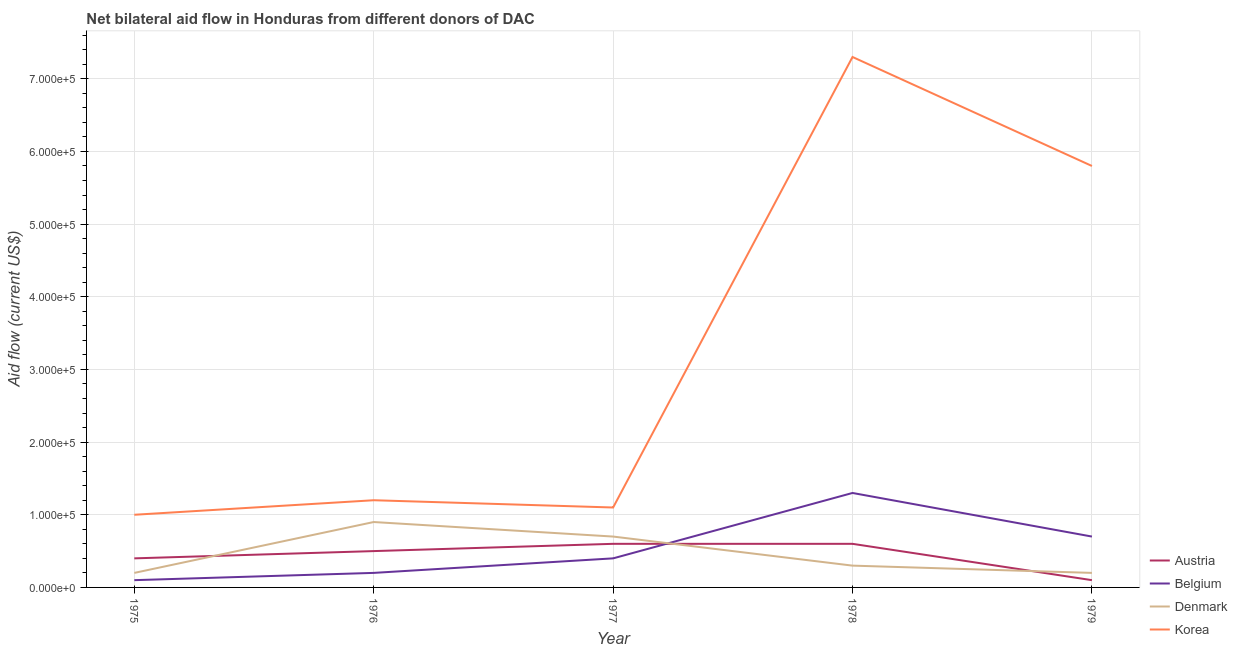Is the number of lines equal to the number of legend labels?
Provide a short and direct response. Yes. What is the amount of aid given by austria in 1978?
Your answer should be very brief. 6.00e+04. Across all years, what is the maximum amount of aid given by austria?
Your response must be concise. 6.00e+04. Across all years, what is the minimum amount of aid given by denmark?
Provide a short and direct response. 2.00e+04. In which year was the amount of aid given by austria minimum?
Offer a very short reply. 1979. What is the total amount of aid given by belgium in the graph?
Ensure brevity in your answer.  2.70e+05. What is the difference between the amount of aid given by austria in 1976 and that in 1977?
Provide a succinct answer. -10000. What is the difference between the amount of aid given by austria in 1975 and the amount of aid given by korea in 1977?
Offer a terse response. -7.00e+04. What is the average amount of aid given by denmark per year?
Make the answer very short. 4.60e+04. In the year 1979, what is the difference between the amount of aid given by belgium and amount of aid given by austria?
Ensure brevity in your answer.  6.00e+04. What is the ratio of the amount of aid given by denmark in 1977 to that in 1978?
Your response must be concise. 2.33. Is the amount of aid given by belgium in 1977 less than that in 1978?
Give a very brief answer. Yes. Is the difference between the amount of aid given by belgium in 1976 and 1978 greater than the difference between the amount of aid given by korea in 1976 and 1978?
Make the answer very short. Yes. What is the difference between the highest and the lowest amount of aid given by korea?
Ensure brevity in your answer.  6.30e+05. In how many years, is the amount of aid given by belgium greater than the average amount of aid given by belgium taken over all years?
Your answer should be compact. 2. Is the sum of the amount of aid given by korea in 1975 and 1976 greater than the maximum amount of aid given by belgium across all years?
Your answer should be very brief. Yes. Is it the case that in every year, the sum of the amount of aid given by denmark and amount of aid given by korea is greater than the sum of amount of aid given by austria and amount of aid given by belgium?
Keep it short and to the point. No. Does the amount of aid given by korea monotonically increase over the years?
Provide a succinct answer. No. Is the amount of aid given by austria strictly less than the amount of aid given by korea over the years?
Your response must be concise. Yes. How many years are there in the graph?
Make the answer very short. 5. What is the difference between two consecutive major ticks on the Y-axis?
Provide a succinct answer. 1.00e+05. Does the graph contain grids?
Your response must be concise. Yes. How many legend labels are there?
Offer a terse response. 4. How are the legend labels stacked?
Your answer should be compact. Vertical. What is the title of the graph?
Offer a terse response. Net bilateral aid flow in Honduras from different donors of DAC. What is the label or title of the X-axis?
Your answer should be compact. Year. What is the Aid flow (current US$) in Korea in 1975?
Your response must be concise. 1.00e+05. What is the Aid flow (current US$) of Austria in 1976?
Your response must be concise. 5.00e+04. What is the Aid flow (current US$) in Belgium in 1976?
Your response must be concise. 2.00e+04. What is the Aid flow (current US$) in Denmark in 1976?
Keep it short and to the point. 9.00e+04. What is the Aid flow (current US$) of Austria in 1977?
Your response must be concise. 6.00e+04. What is the Aid flow (current US$) of Belgium in 1977?
Provide a succinct answer. 4.00e+04. What is the Aid flow (current US$) of Denmark in 1977?
Your answer should be compact. 7.00e+04. What is the Aid flow (current US$) of Austria in 1978?
Your response must be concise. 6.00e+04. What is the Aid flow (current US$) of Belgium in 1978?
Give a very brief answer. 1.30e+05. What is the Aid flow (current US$) of Denmark in 1978?
Make the answer very short. 3.00e+04. What is the Aid flow (current US$) of Korea in 1978?
Keep it short and to the point. 7.30e+05. What is the Aid flow (current US$) of Denmark in 1979?
Give a very brief answer. 2.00e+04. What is the Aid flow (current US$) in Korea in 1979?
Your answer should be compact. 5.80e+05. Across all years, what is the maximum Aid flow (current US$) in Belgium?
Offer a terse response. 1.30e+05. Across all years, what is the maximum Aid flow (current US$) in Denmark?
Your answer should be compact. 9.00e+04. Across all years, what is the maximum Aid flow (current US$) of Korea?
Make the answer very short. 7.30e+05. Across all years, what is the minimum Aid flow (current US$) in Denmark?
Give a very brief answer. 2.00e+04. What is the total Aid flow (current US$) in Austria in the graph?
Your answer should be compact. 2.20e+05. What is the total Aid flow (current US$) in Korea in the graph?
Provide a short and direct response. 1.64e+06. What is the difference between the Aid flow (current US$) in Austria in 1975 and that in 1977?
Make the answer very short. -2.00e+04. What is the difference between the Aid flow (current US$) in Belgium in 1975 and that in 1977?
Ensure brevity in your answer.  -3.00e+04. What is the difference between the Aid flow (current US$) of Korea in 1975 and that in 1977?
Offer a terse response. -10000. What is the difference between the Aid flow (current US$) of Austria in 1975 and that in 1978?
Your response must be concise. -2.00e+04. What is the difference between the Aid flow (current US$) in Belgium in 1975 and that in 1978?
Provide a short and direct response. -1.20e+05. What is the difference between the Aid flow (current US$) of Korea in 1975 and that in 1978?
Your response must be concise. -6.30e+05. What is the difference between the Aid flow (current US$) in Austria in 1975 and that in 1979?
Ensure brevity in your answer.  3.00e+04. What is the difference between the Aid flow (current US$) in Korea in 1975 and that in 1979?
Your response must be concise. -4.80e+05. What is the difference between the Aid flow (current US$) of Austria in 1976 and that in 1978?
Your answer should be compact. -10000. What is the difference between the Aid flow (current US$) in Belgium in 1976 and that in 1978?
Provide a succinct answer. -1.10e+05. What is the difference between the Aid flow (current US$) of Denmark in 1976 and that in 1978?
Provide a short and direct response. 6.00e+04. What is the difference between the Aid flow (current US$) in Korea in 1976 and that in 1978?
Your answer should be very brief. -6.10e+05. What is the difference between the Aid flow (current US$) in Austria in 1976 and that in 1979?
Ensure brevity in your answer.  4.00e+04. What is the difference between the Aid flow (current US$) of Belgium in 1976 and that in 1979?
Your response must be concise. -5.00e+04. What is the difference between the Aid flow (current US$) of Denmark in 1976 and that in 1979?
Offer a terse response. 7.00e+04. What is the difference between the Aid flow (current US$) in Korea in 1976 and that in 1979?
Ensure brevity in your answer.  -4.60e+05. What is the difference between the Aid flow (current US$) of Austria in 1977 and that in 1978?
Offer a terse response. 0. What is the difference between the Aid flow (current US$) of Belgium in 1977 and that in 1978?
Offer a terse response. -9.00e+04. What is the difference between the Aid flow (current US$) in Denmark in 1977 and that in 1978?
Keep it short and to the point. 4.00e+04. What is the difference between the Aid flow (current US$) of Korea in 1977 and that in 1978?
Keep it short and to the point. -6.20e+05. What is the difference between the Aid flow (current US$) in Belgium in 1977 and that in 1979?
Make the answer very short. -3.00e+04. What is the difference between the Aid flow (current US$) of Denmark in 1977 and that in 1979?
Provide a short and direct response. 5.00e+04. What is the difference between the Aid flow (current US$) of Korea in 1977 and that in 1979?
Make the answer very short. -4.70e+05. What is the difference between the Aid flow (current US$) of Austria in 1978 and that in 1979?
Ensure brevity in your answer.  5.00e+04. What is the difference between the Aid flow (current US$) in Denmark in 1978 and that in 1979?
Your response must be concise. 10000. What is the difference between the Aid flow (current US$) in Belgium in 1975 and the Aid flow (current US$) in Denmark in 1976?
Offer a terse response. -8.00e+04. What is the difference between the Aid flow (current US$) in Austria in 1975 and the Aid flow (current US$) in Belgium in 1977?
Provide a succinct answer. 0. What is the difference between the Aid flow (current US$) of Austria in 1975 and the Aid flow (current US$) of Denmark in 1977?
Provide a short and direct response. -3.00e+04. What is the difference between the Aid flow (current US$) in Austria in 1975 and the Aid flow (current US$) in Korea in 1977?
Offer a very short reply. -7.00e+04. What is the difference between the Aid flow (current US$) of Belgium in 1975 and the Aid flow (current US$) of Denmark in 1977?
Make the answer very short. -6.00e+04. What is the difference between the Aid flow (current US$) of Austria in 1975 and the Aid flow (current US$) of Belgium in 1978?
Provide a short and direct response. -9.00e+04. What is the difference between the Aid flow (current US$) in Austria in 1975 and the Aid flow (current US$) in Denmark in 1978?
Make the answer very short. 10000. What is the difference between the Aid flow (current US$) of Austria in 1975 and the Aid flow (current US$) of Korea in 1978?
Provide a succinct answer. -6.90e+05. What is the difference between the Aid flow (current US$) of Belgium in 1975 and the Aid flow (current US$) of Korea in 1978?
Keep it short and to the point. -7.20e+05. What is the difference between the Aid flow (current US$) in Denmark in 1975 and the Aid flow (current US$) in Korea in 1978?
Keep it short and to the point. -7.10e+05. What is the difference between the Aid flow (current US$) of Austria in 1975 and the Aid flow (current US$) of Belgium in 1979?
Your response must be concise. -3.00e+04. What is the difference between the Aid flow (current US$) in Austria in 1975 and the Aid flow (current US$) in Korea in 1979?
Make the answer very short. -5.40e+05. What is the difference between the Aid flow (current US$) in Belgium in 1975 and the Aid flow (current US$) in Denmark in 1979?
Offer a very short reply. -10000. What is the difference between the Aid flow (current US$) of Belgium in 1975 and the Aid flow (current US$) of Korea in 1979?
Ensure brevity in your answer.  -5.70e+05. What is the difference between the Aid flow (current US$) in Denmark in 1975 and the Aid flow (current US$) in Korea in 1979?
Provide a short and direct response. -5.60e+05. What is the difference between the Aid flow (current US$) in Austria in 1976 and the Aid flow (current US$) in Belgium in 1977?
Give a very brief answer. 10000. What is the difference between the Aid flow (current US$) in Austria in 1976 and the Aid flow (current US$) in Korea in 1977?
Your answer should be very brief. -6.00e+04. What is the difference between the Aid flow (current US$) in Denmark in 1976 and the Aid flow (current US$) in Korea in 1977?
Make the answer very short. -2.00e+04. What is the difference between the Aid flow (current US$) in Austria in 1976 and the Aid flow (current US$) in Belgium in 1978?
Your answer should be very brief. -8.00e+04. What is the difference between the Aid flow (current US$) in Austria in 1976 and the Aid flow (current US$) in Denmark in 1978?
Your response must be concise. 2.00e+04. What is the difference between the Aid flow (current US$) in Austria in 1976 and the Aid flow (current US$) in Korea in 1978?
Offer a terse response. -6.80e+05. What is the difference between the Aid flow (current US$) of Belgium in 1976 and the Aid flow (current US$) of Denmark in 1978?
Ensure brevity in your answer.  -10000. What is the difference between the Aid flow (current US$) of Belgium in 1976 and the Aid flow (current US$) of Korea in 1978?
Provide a succinct answer. -7.10e+05. What is the difference between the Aid flow (current US$) of Denmark in 1976 and the Aid flow (current US$) of Korea in 1978?
Provide a succinct answer. -6.40e+05. What is the difference between the Aid flow (current US$) in Austria in 1976 and the Aid flow (current US$) in Belgium in 1979?
Make the answer very short. -2.00e+04. What is the difference between the Aid flow (current US$) in Austria in 1976 and the Aid flow (current US$) in Korea in 1979?
Offer a very short reply. -5.30e+05. What is the difference between the Aid flow (current US$) of Belgium in 1976 and the Aid flow (current US$) of Denmark in 1979?
Provide a short and direct response. 0. What is the difference between the Aid flow (current US$) of Belgium in 1976 and the Aid flow (current US$) of Korea in 1979?
Make the answer very short. -5.60e+05. What is the difference between the Aid flow (current US$) of Denmark in 1976 and the Aid flow (current US$) of Korea in 1979?
Your response must be concise. -4.90e+05. What is the difference between the Aid flow (current US$) of Austria in 1977 and the Aid flow (current US$) of Belgium in 1978?
Ensure brevity in your answer.  -7.00e+04. What is the difference between the Aid flow (current US$) in Austria in 1977 and the Aid flow (current US$) in Denmark in 1978?
Your answer should be compact. 3.00e+04. What is the difference between the Aid flow (current US$) in Austria in 1977 and the Aid flow (current US$) in Korea in 1978?
Ensure brevity in your answer.  -6.70e+05. What is the difference between the Aid flow (current US$) in Belgium in 1977 and the Aid flow (current US$) in Denmark in 1978?
Offer a terse response. 10000. What is the difference between the Aid flow (current US$) of Belgium in 1977 and the Aid flow (current US$) of Korea in 1978?
Offer a very short reply. -6.90e+05. What is the difference between the Aid flow (current US$) in Denmark in 1977 and the Aid flow (current US$) in Korea in 1978?
Provide a succinct answer. -6.60e+05. What is the difference between the Aid flow (current US$) of Austria in 1977 and the Aid flow (current US$) of Denmark in 1979?
Give a very brief answer. 4.00e+04. What is the difference between the Aid flow (current US$) of Austria in 1977 and the Aid flow (current US$) of Korea in 1979?
Ensure brevity in your answer.  -5.20e+05. What is the difference between the Aid flow (current US$) of Belgium in 1977 and the Aid flow (current US$) of Korea in 1979?
Provide a succinct answer. -5.40e+05. What is the difference between the Aid flow (current US$) of Denmark in 1977 and the Aid flow (current US$) of Korea in 1979?
Provide a succinct answer. -5.10e+05. What is the difference between the Aid flow (current US$) in Austria in 1978 and the Aid flow (current US$) in Denmark in 1979?
Your answer should be very brief. 4.00e+04. What is the difference between the Aid flow (current US$) in Austria in 1978 and the Aid flow (current US$) in Korea in 1979?
Your answer should be very brief. -5.20e+05. What is the difference between the Aid flow (current US$) of Belgium in 1978 and the Aid flow (current US$) of Denmark in 1979?
Your response must be concise. 1.10e+05. What is the difference between the Aid flow (current US$) of Belgium in 1978 and the Aid flow (current US$) of Korea in 1979?
Your answer should be very brief. -4.50e+05. What is the difference between the Aid flow (current US$) of Denmark in 1978 and the Aid flow (current US$) of Korea in 1979?
Provide a succinct answer. -5.50e+05. What is the average Aid flow (current US$) in Austria per year?
Your response must be concise. 4.40e+04. What is the average Aid flow (current US$) of Belgium per year?
Your answer should be compact. 5.40e+04. What is the average Aid flow (current US$) of Denmark per year?
Offer a very short reply. 4.60e+04. What is the average Aid flow (current US$) of Korea per year?
Offer a terse response. 3.28e+05. In the year 1975, what is the difference between the Aid flow (current US$) of Austria and Aid flow (current US$) of Belgium?
Your response must be concise. 3.00e+04. In the year 1975, what is the difference between the Aid flow (current US$) in Belgium and Aid flow (current US$) in Denmark?
Your answer should be compact. -10000. In the year 1976, what is the difference between the Aid flow (current US$) in Austria and Aid flow (current US$) in Belgium?
Give a very brief answer. 3.00e+04. In the year 1976, what is the difference between the Aid flow (current US$) of Austria and Aid flow (current US$) of Korea?
Your response must be concise. -7.00e+04. In the year 1976, what is the difference between the Aid flow (current US$) of Belgium and Aid flow (current US$) of Korea?
Provide a short and direct response. -1.00e+05. In the year 1977, what is the difference between the Aid flow (current US$) in Austria and Aid flow (current US$) in Denmark?
Ensure brevity in your answer.  -10000. In the year 1977, what is the difference between the Aid flow (current US$) in Austria and Aid flow (current US$) in Korea?
Make the answer very short. -5.00e+04. In the year 1977, what is the difference between the Aid flow (current US$) in Denmark and Aid flow (current US$) in Korea?
Your answer should be very brief. -4.00e+04. In the year 1978, what is the difference between the Aid flow (current US$) of Austria and Aid flow (current US$) of Belgium?
Give a very brief answer. -7.00e+04. In the year 1978, what is the difference between the Aid flow (current US$) in Austria and Aid flow (current US$) in Korea?
Provide a succinct answer. -6.70e+05. In the year 1978, what is the difference between the Aid flow (current US$) of Belgium and Aid flow (current US$) of Korea?
Your answer should be very brief. -6.00e+05. In the year 1978, what is the difference between the Aid flow (current US$) of Denmark and Aid flow (current US$) of Korea?
Keep it short and to the point. -7.00e+05. In the year 1979, what is the difference between the Aid flow (current US$) of Austria and Aid flow (current US$) of Denmark?
Your answer should be very brief. -10000. In the year 1979, what is the difference between the Aid flow (current US$) in Austria and Aid flow (current US$) in Korea?
Give a very brief answer. -5.70e+05. In the year 1979, what is the difference between the Aid flow (current US$) in Belgium and Aid flow (current US$) in Denmark?
Offer a very short reply. 5.00e+04. In the year 1979, what is the difference between the Aid flow (current US$) of Belgium and Aid flow (current US$) of Korea?
Give a very brief answer. -5.10e+05. In the year 1979, what is the difference between the Aid flow (current US$) in Denmark and Aid flow (current US$) in Korea?
Ensure brevity in your answer.  -5.60e+05. What is the ratio of the Aid flow (current US$) of Belgium in 1975 to that in 1976?
Give a very brief answer. 0.5. What is the ratio of the Aid flow (current US$) of Denmark in 1975 to that in 1976?
Offer a terse response. 0.22. What is the ratio of the Aid flow (current US$) in Austria in 1975 to that in 1977?
Keep it short and to the point. 0.67. What is the ratio of the Aid flow (current US$) in Denmark in 1975 to that in 1977?
Your response must be concise. 0.29. What is the ratio of the Aid flow (current US$) of Korea in 1975 to that in 1977?
Your answer should be very brief. 0.91. What is the ratio of the Aid flow (current US$) of Austria in 1975 to that in 1978?
Provide a short and direct response. 0.67. What is the ratio of the Aid flow (current US$) in Belgium in 1975 to that in 1978?
Provide a short and direct response. 0.08. What is the ratio of the Aid flow (current US$) in Denmark in 1975 to that in 1978?
Your response must be concise. 0.67. What is the ratio of the Aid flow (current US$) in Korea in 1975 to that in 1978?
Provide a succinct answer. 0.14. What is the ratio of the Aid flow (current US$) of Belgium in 1975 to that in 1979?
Make the answer very short. 0.14. What is the ratio of the Aid flow (current US$) in Korea in 1975 to that in 1979?
Offer a terse response. 0.17. What is the ratio of the Aid flow (current US$) of Belgium in 1976 to that in 1977?
Make the answer very short. 0.5. What is the ratio of the Aid flow (current US$) in Denmark in 1976 to that in 1977?
Keep it short and to the point. 1.29. What is the ratio of the Aid flow (current US$) in Belgium in 1976 to that in 1978?
Ensure brevity in your answer.  0.15. What is the ratio of the Aid flow (current US$) of Denmark in 1976 to that in 1978?
Ensure brevity in your answer.  3. What is the ratio of the Aid flow (current US$) in Korea in 1976 to that in 1978?
Provide a short and direct response. 0.16. What is the ratio of the Aid flow (current US$) of Austria in 1976 to that in 1979?
Offer a terse response. 5. What is the ratio of the Aid flow (current US$) of Belgium in 1976 to that in 1979?
Your response must be concise. 0.29. What is the ratio of the Aid flow (current US$) in Korea in 1976 to that in 1979?
Make the answer very short. 0.21. What is the ratio of the Aid flow (current US$) in Belgium in 1977 to that in 1978?
Provide a short and direct response. 0.31. What is the ratio of the Aid flow (current US$) in Denmark in 1977 to that in 1978?
Provide a short and direct response. 2.33. What is the ratio of the Aid flow (current US$) of Korea in 1977 to that in 1978?
Your answer should be compact. 0.15. What is the ratio of the Aid flow (current US$) of Denmark in 1977 to that in 1979?
Offer a terse response. 3.5. What is the ratio of the Aid flow (current US$) of Korea in 1977 to that in 1979?
Your response must be concise. 0.19. What is the ratio of the Aid flow (current US$) in Belgium in 1978 to that in 1979?
Offer a very short reply. 1.86. What is the ratio of the Aid flow (current US$) of Denmark in 1978 to that in 1979?
Make the answer very short. 1.5. What is the ratio of the Aid flow (current US$) of Korea in 1978 to that in 1979?
Provide a short and direct response. 1.26. What is the difference between the highest and the second highest Aid flow (current US$) of Denmark?
Offer a very short reply. 2.00e+04. What is the difference between the highest and the lowest Aid flow (current US$) of Korea?
Keep it short and to the point. 6.30e+05. 